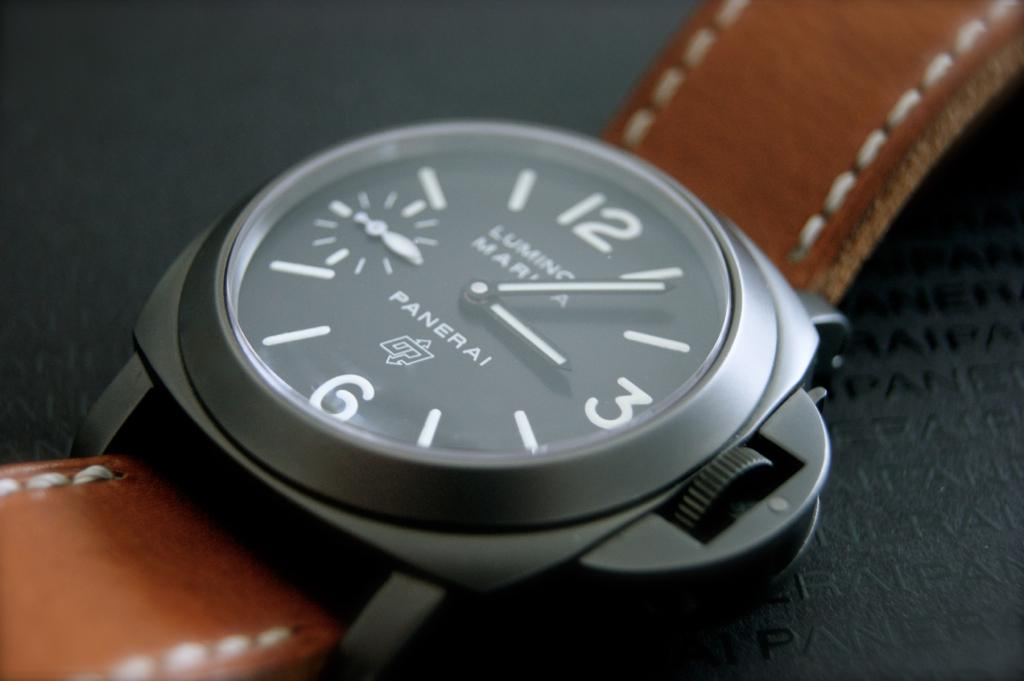Can you give me a brief history of the Panerai brand? The Panerai brand began in Florence, Italy, in 1860 as a watch shop and later developed into a manufacturer of precision instruments. During the mid-20th century, Panerai was known for supplying the Italian Navy with diving instruments. The brand became famous for its distinctive large watches and gained a public following in the 1990s. Panerai watches are now celebrated for their unique blend of Italian design and Swiss technology. 